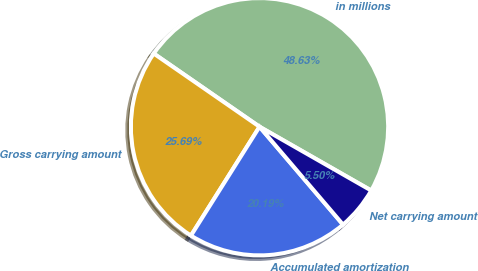<chart> <loc_0><loc_0><loc_500><loc_500><pie_chart><fcel>in millions<fcel>Gross carrying amount<fcel>Accumulated amortization<fcel>Net carrying amount<nl><fcel>48.63%<fcel>25.69%<fcel>20.19%<fcel>5.5%<nl></chart> 